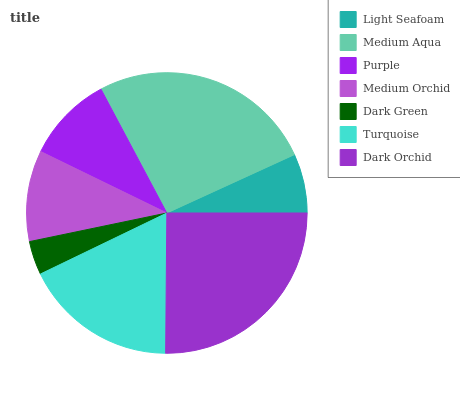Is Dark Green the minimum?
Answer yes or no. Yes. Is Medium Aqua the maximum?
Answer yes or no. Yes. Is Purple the minimum?
Answer yes or no. No. Is Purple the maximum?
Answer yes or no. No. Is Medium Aqua greater than Purple?
Answer yes or no. Yes. Is Purple less than Medium Aqua?
Answer yes or no. Yes. Is Purple greater than Medium Aqua?
Answer yes or no. No. Is Medium Aqua less than Purple?
Answer yes or no. No. Is Medium Orchid the high median?
Answer yes or no. Yes. Is Medium Orchid the low median?
Answer yes or no. Yes. Is Dark Orchid the high median?
Answer yes or no. No. Is Turquoise the low median?
Answer yes or no. No. 